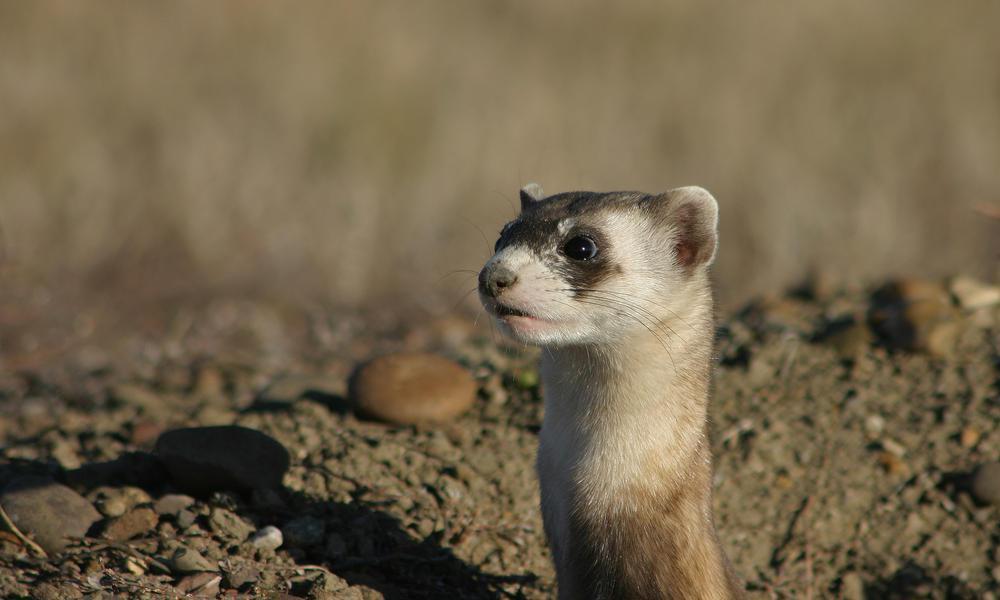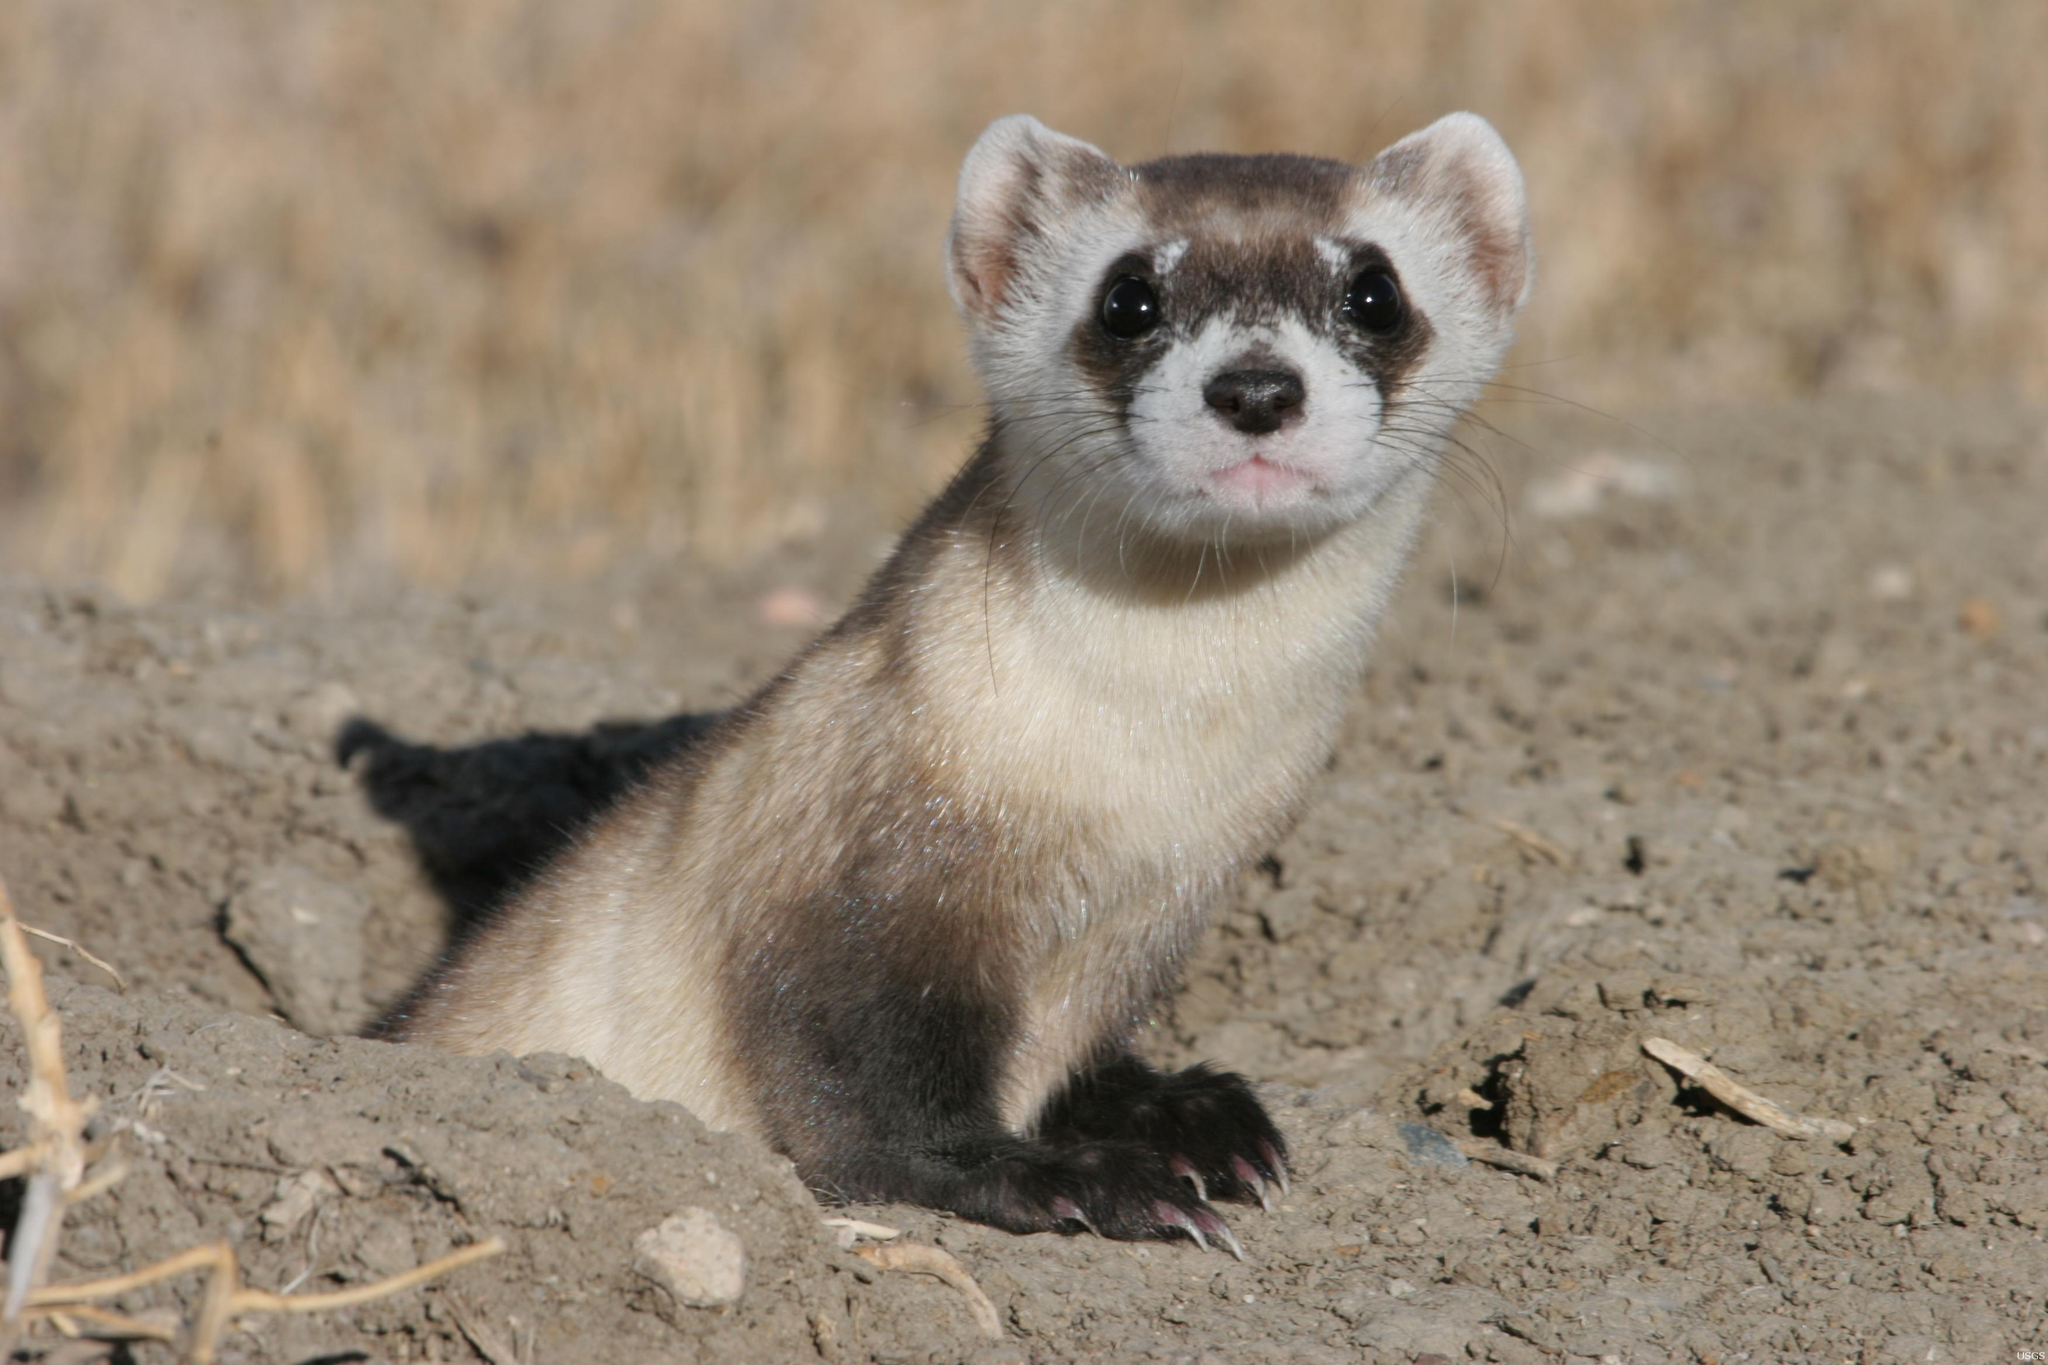The first image is the image on the left, the second image is the image on the right. For the images displayed, is the sentence "The animal in the image on the right is holding one paw off the ground." factually correct? Answer yes or no. No. 